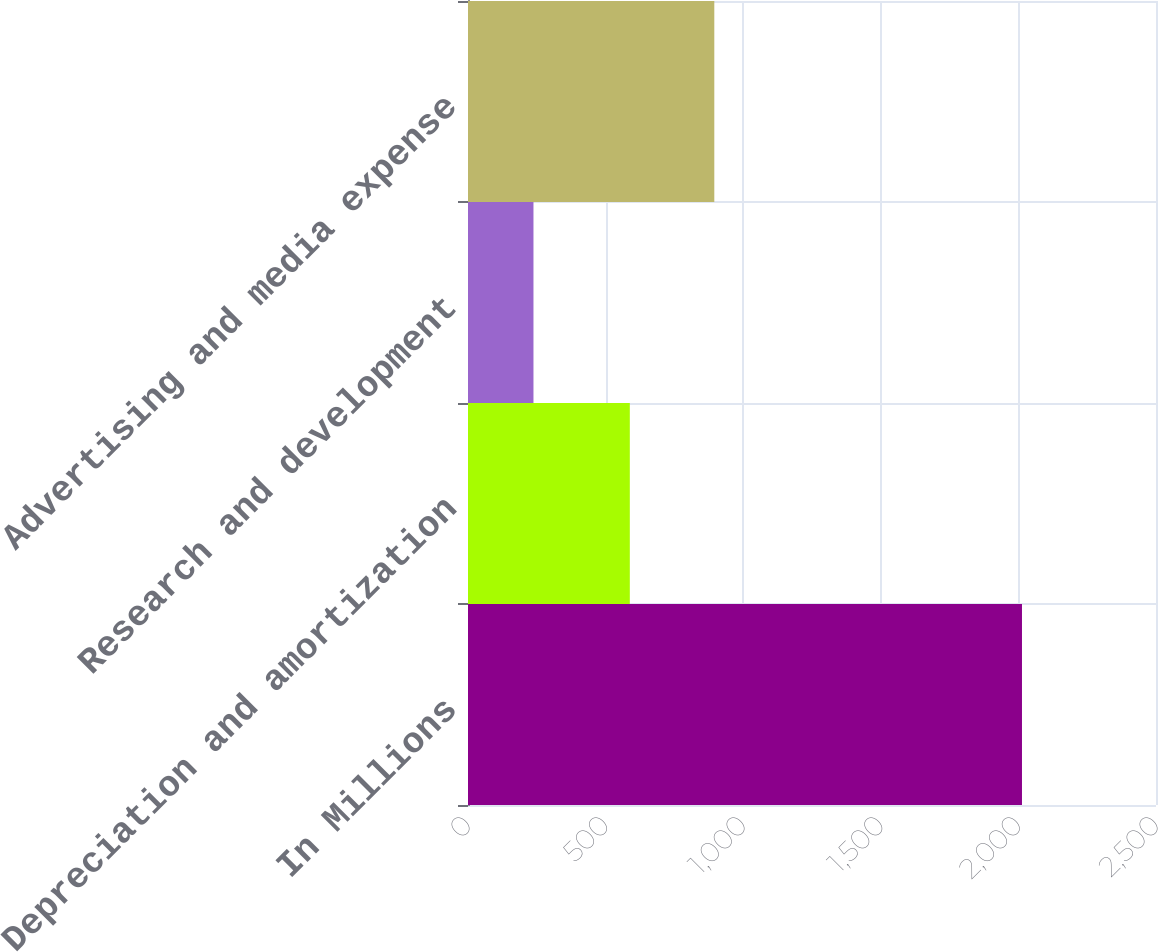<chart> <loc_0><loc_0><loc_500><loc_500><bar_chart><fcel>In Millions<fcel>Depreciation and amortization<fcel>Research and development<fcel>Advertising and media expense<nl><fcel>2013<fcel>588<fcel>237.9<fcel>895<nl></chart> 